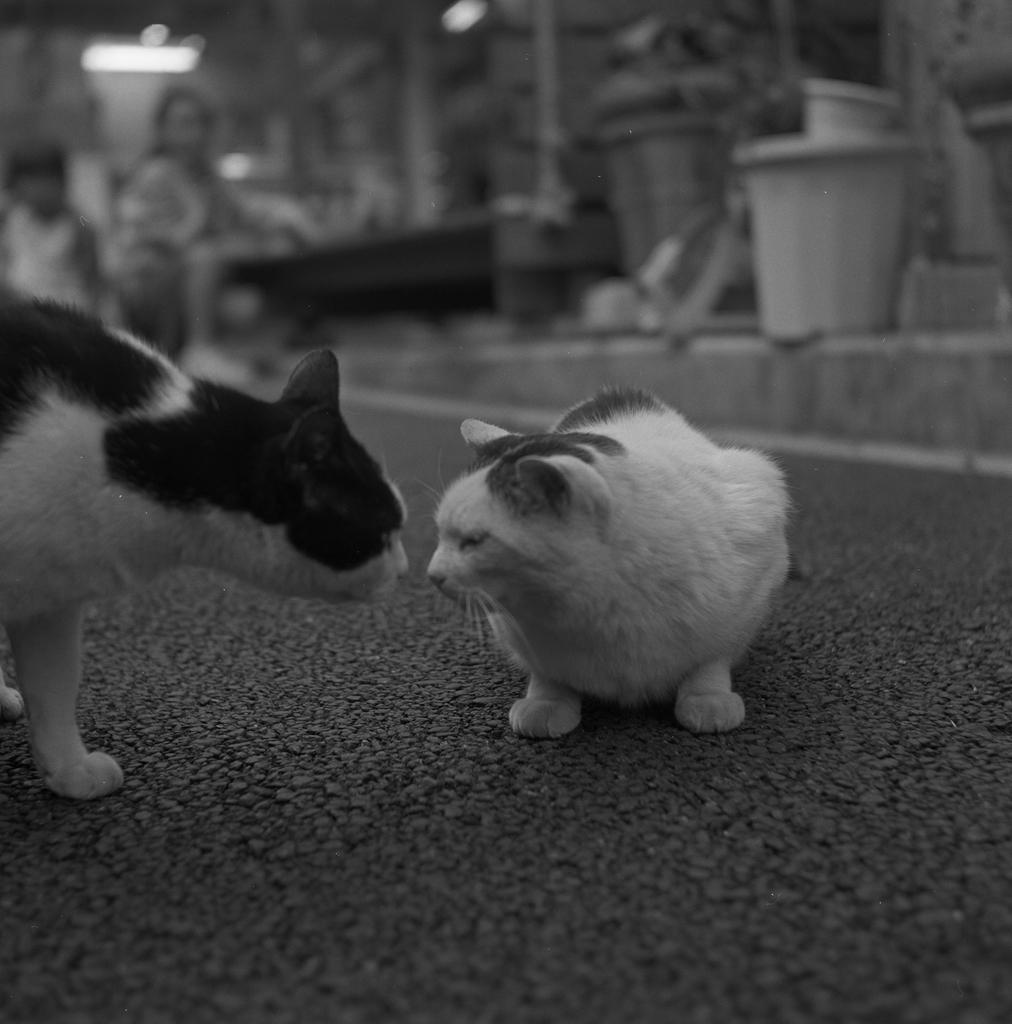What is the color scheme of the image? The image is black and white. How many cats are present in the picture? There are two cats in the picture. What is the interaction between the cats? The cats are facing each other. What can be observed about the background of the cats? The background of the cats is blurred. What type of apparel is the cat wearing on its trip? There is no cat wearing apparel on a trip in the image, as it is a black and white picture of two cats facing each other with a blurred background. 